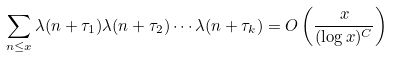Convert formula to latex. <formula><loc_0><loc_0><loc_500><loc_500>\sum _ { n \leq x } \lambda ( n + \tau _ { 1 } ) \lambda ( n + \tau _ { 2 } ) \cdots \lambda ( n + \tau _ { k } ) = O \left ( \frac { x } { ( \log x ) ^ { C } } \right )</formula> 